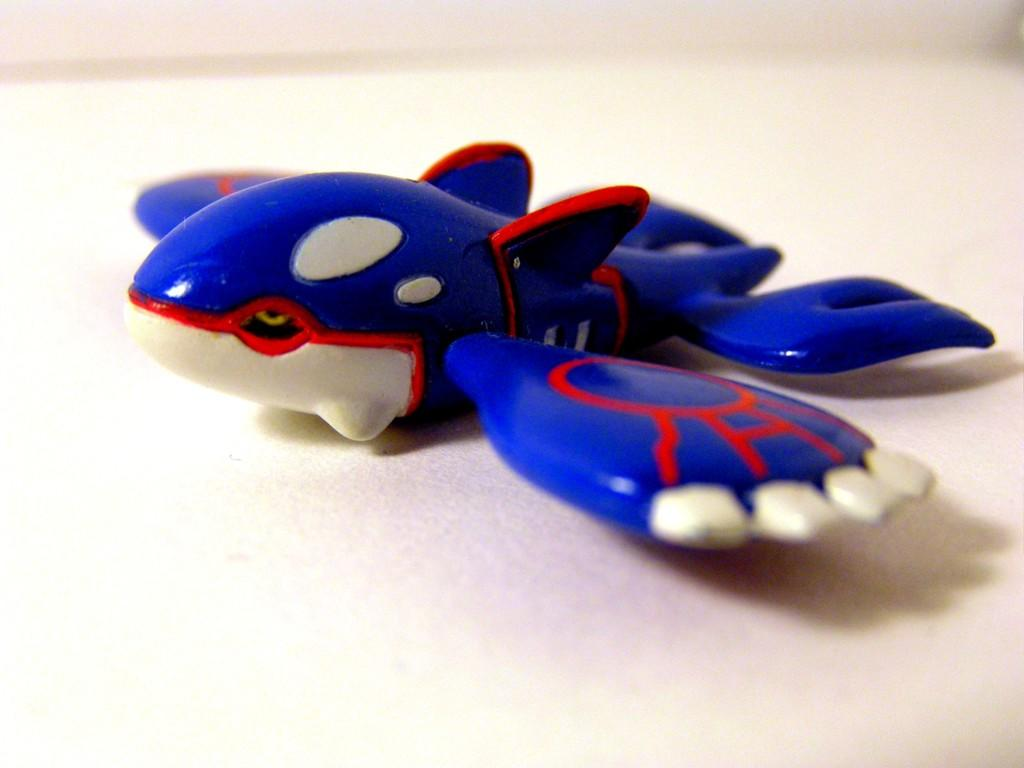What is placed on the ground in the image? There is an object placed on the ground in the image. What type of appliance is visible in the image? There is no appliance present in the image; only an object placed on the ground is mentioned. How many quarters can be seen in the image? There are no quarters present in the image. 